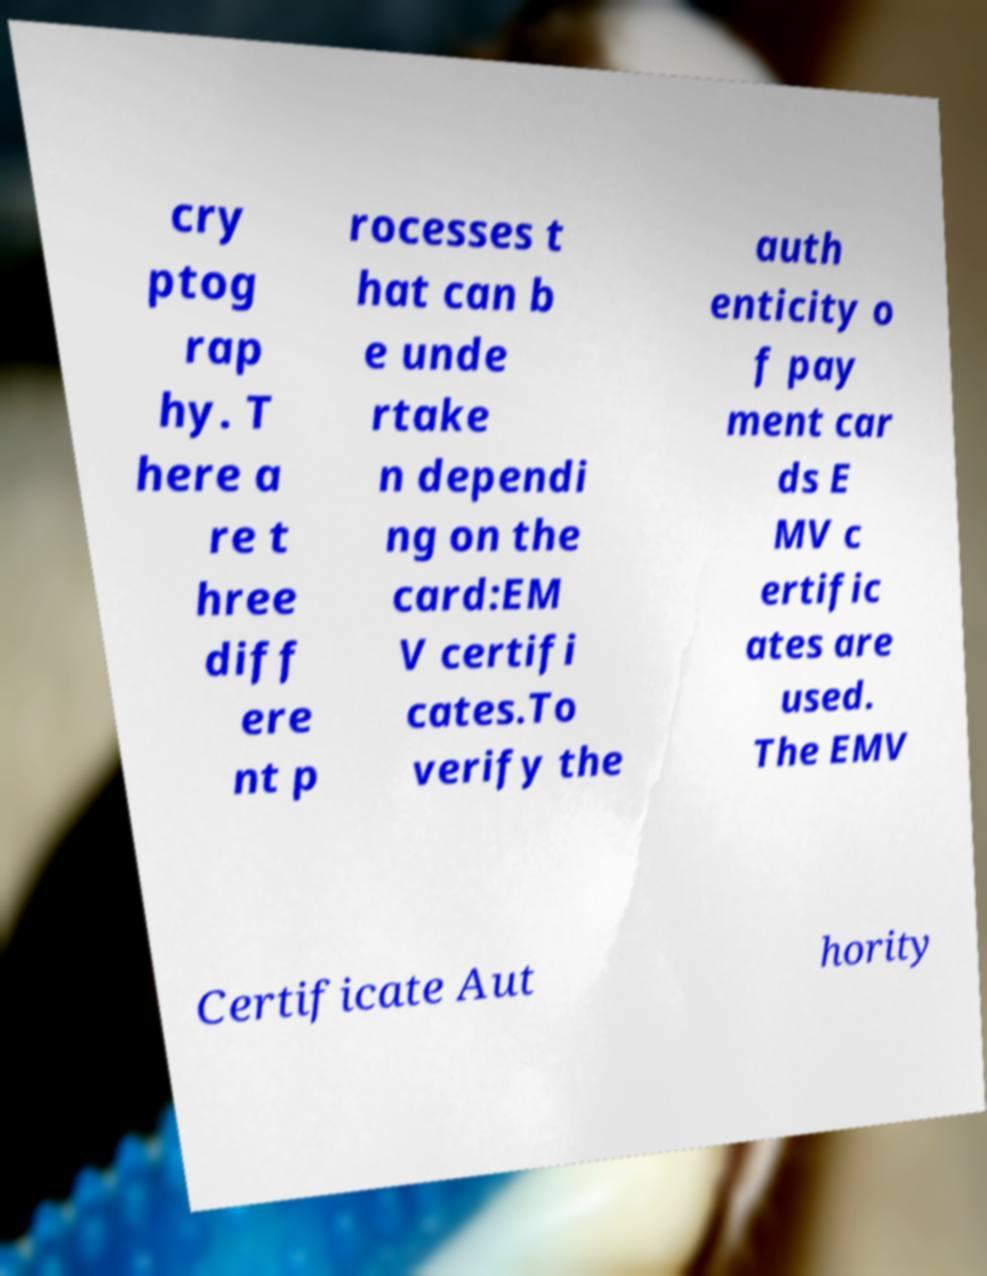Please read and relay the text visible in this image. What does it say? cry ptog rap hy. T here a re t hree diff ere nt p rocesses t hat can b e unde rtake n dependi ng on the card:EM V certifi cates.To verify the auth enticity o f pay ment car ds E MV c ertific ates are used. The EMV Certificate Aut hority 